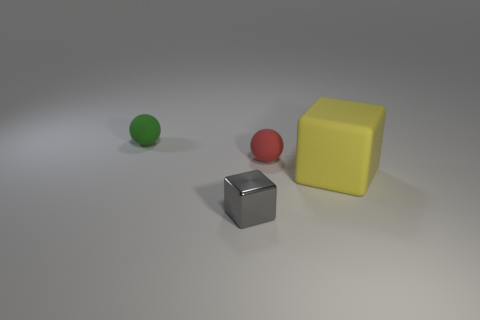Add 3 big red metallic cubes. How many objects exist? 7 Subtract 0 yellow cylinders. How many objects are left? 4 Subtract all gray metallic cubes. Subtract all green rubber cylinders. How many objects are left? 3 Add 1 matte cubes. How many matte cubes are left? 2 Add 3 large yellow matte cubes. How many large yellow matte cubes exist? 4 